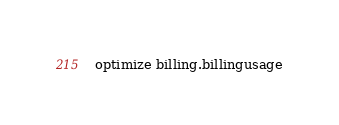<code> <loc_0><loc_0><loc_500><loc_500><_SQL_>optimize billing.billingusage
</code> 